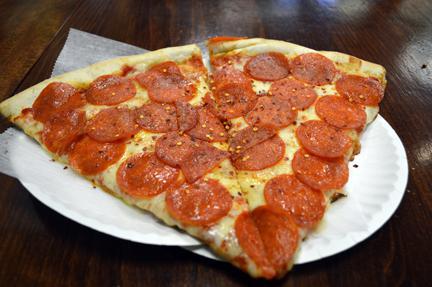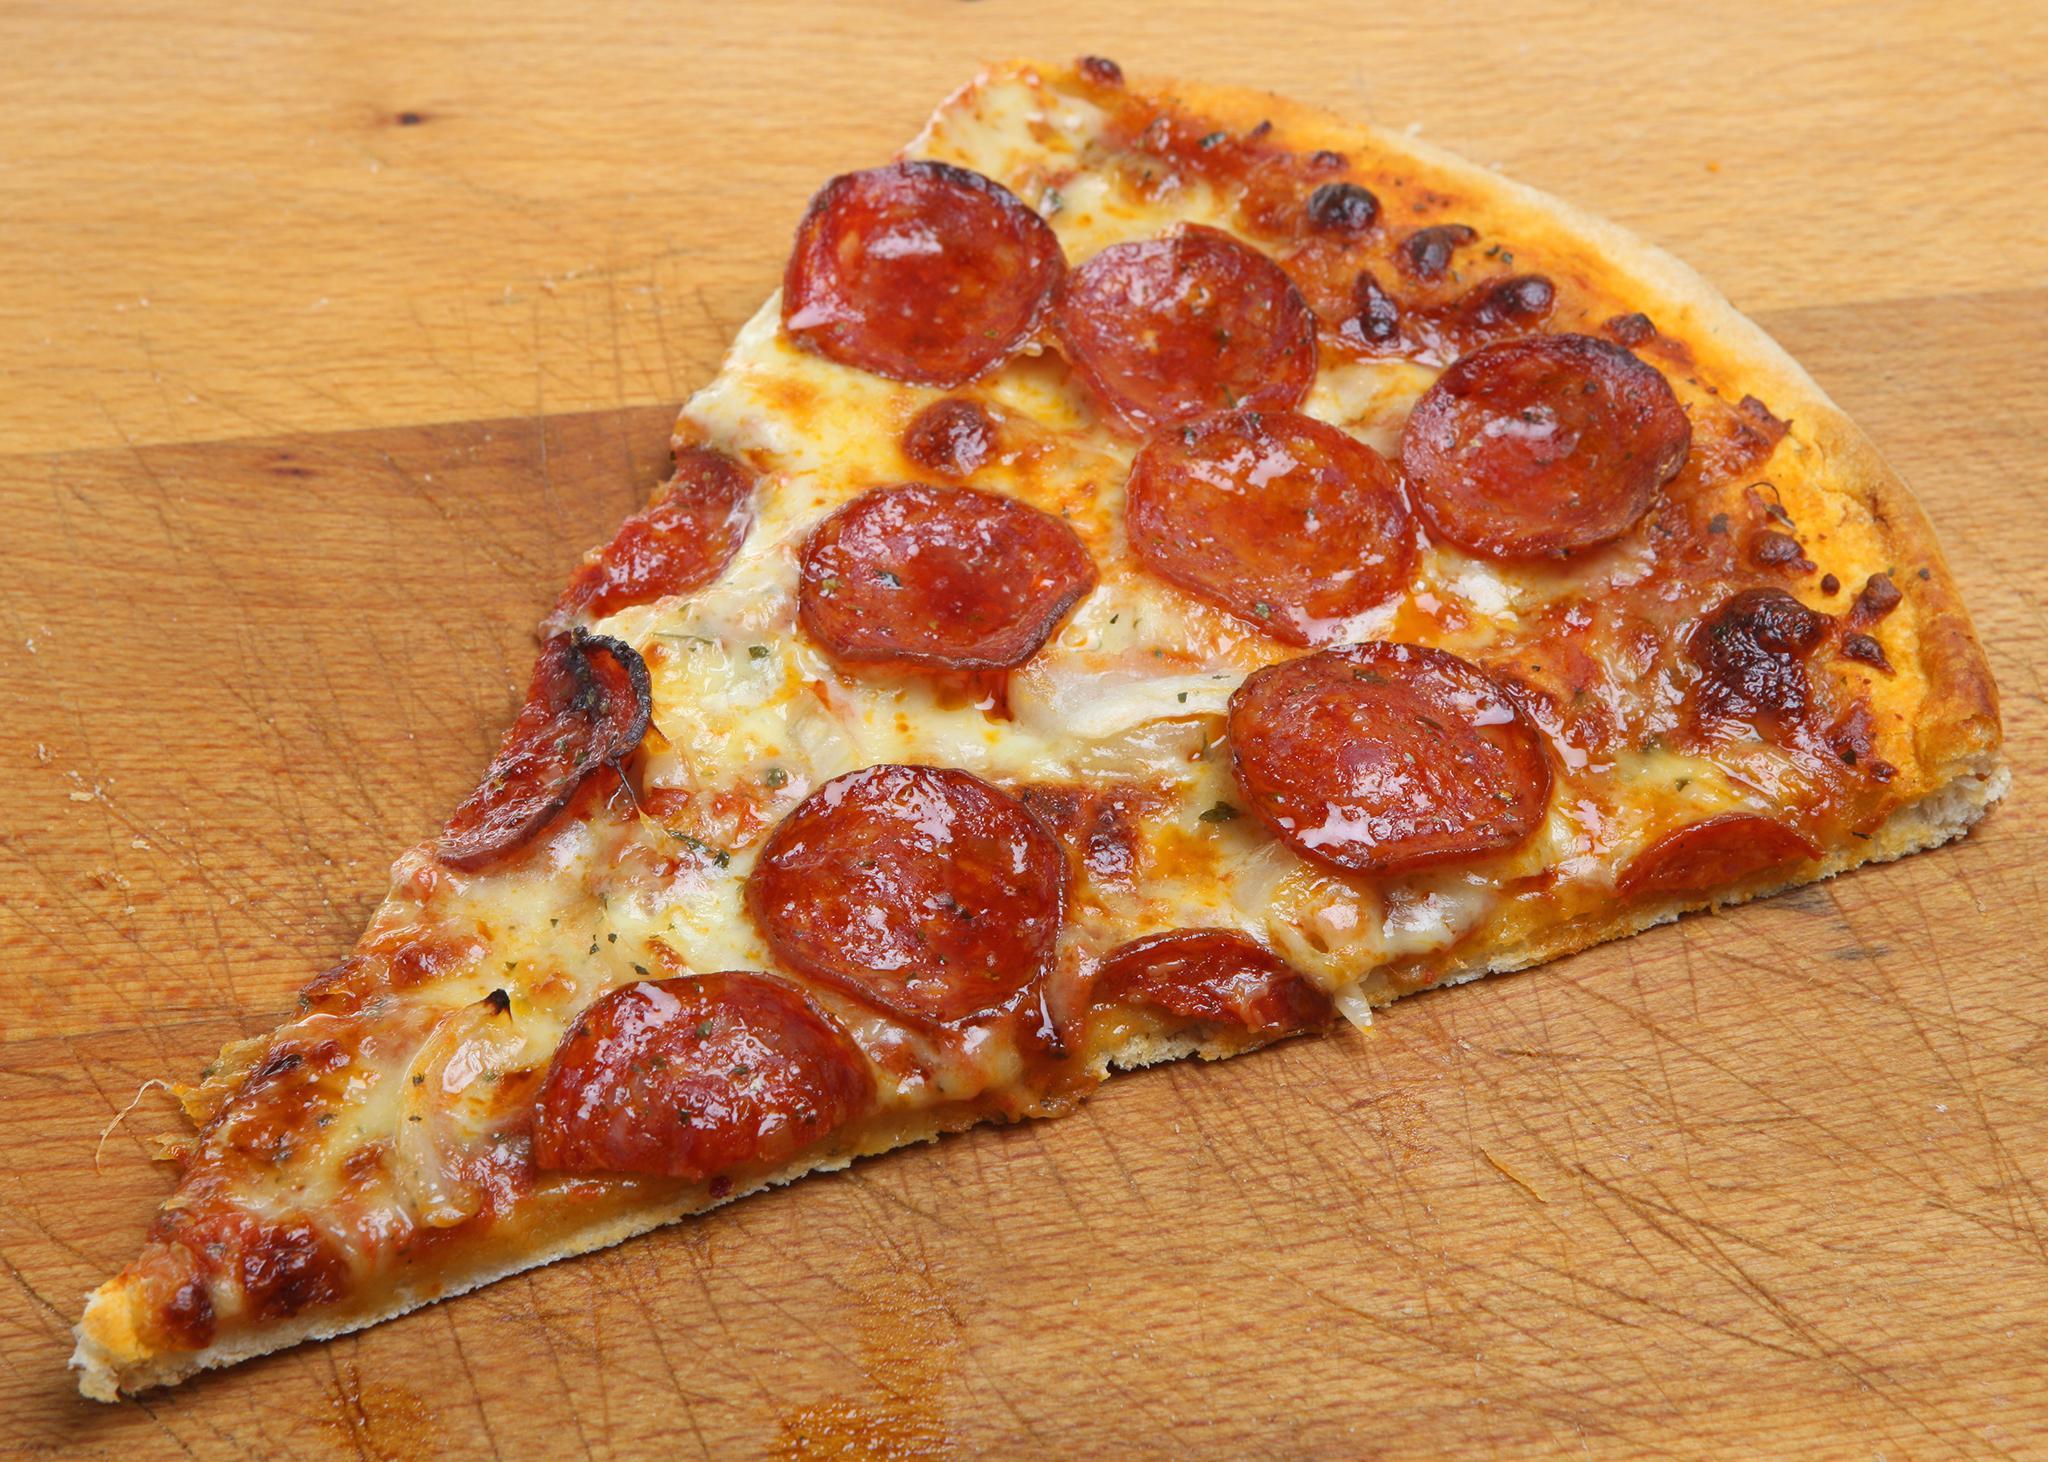The first image is the image on the left, the second image is the image on the right. Evaluate the accuracy of this statement regarding the images: "None of the pizza shown has pepperoni on it.". Is it true? Answer yes or no. No. The first image is the image on the left, the second image is the image on the right. Assess this claim about the two images: "There are pepperoni slices on top of the cheese layer on the pizza.". Correct or not? Answer yes or no. Yes. 